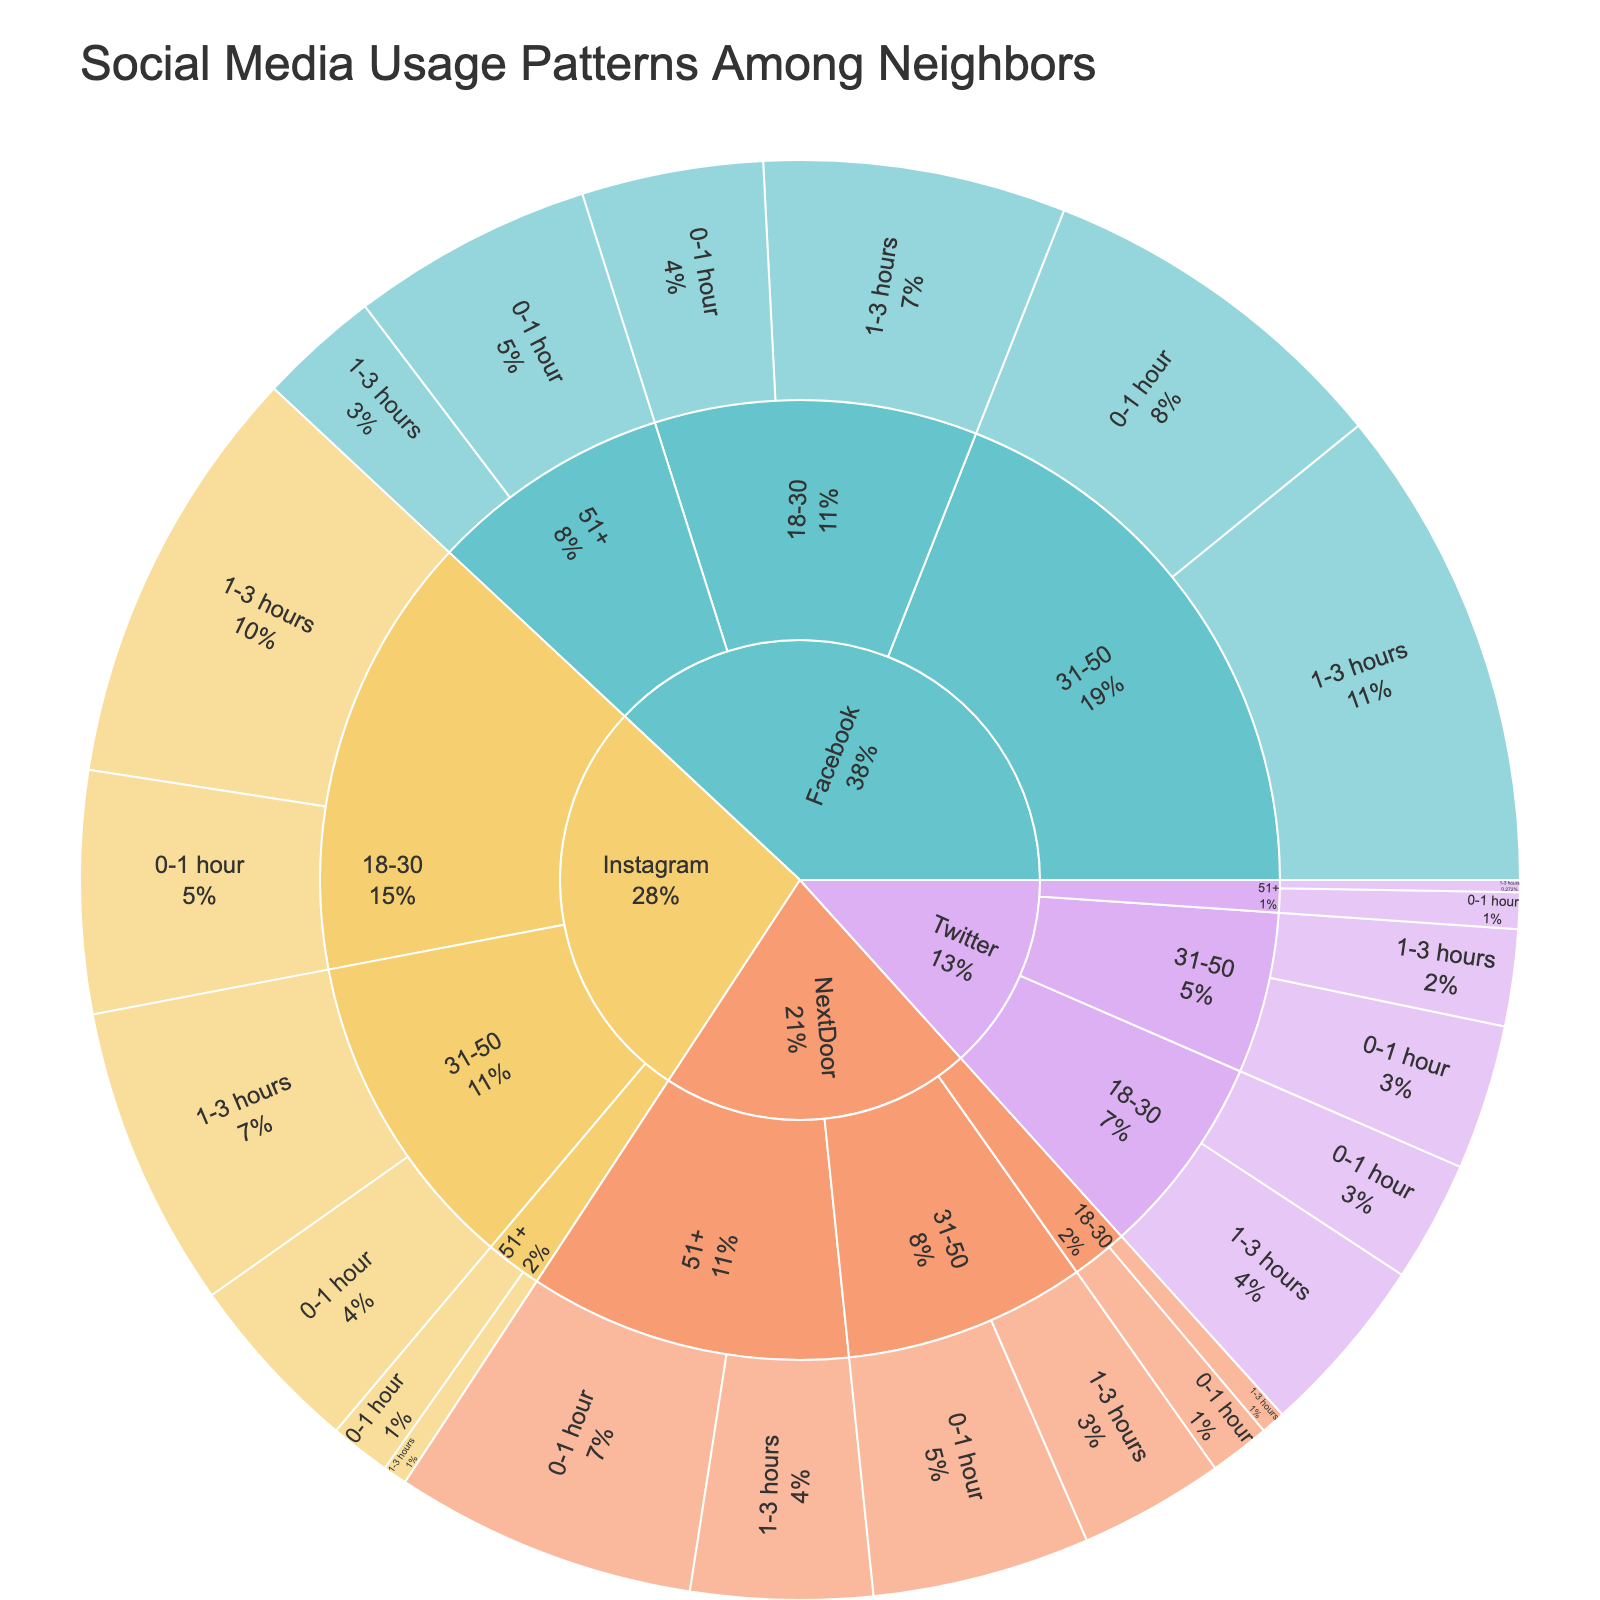What is the overall title of the figure? The overall title can be found at the top of the figure in larger and bold text. It usually provides the main context or subject of the plot. In this case, it is easily observable.
Answer: Social Media Usage Patterns Among Neighbors Which platform has the most users aged 51+ spending 0-1 hour online? To find this, look at the section for each platform (Facebook, Instagram, Twitter, NextDoor) under the '51+' age group and check the '0-1 hour' slice to see the number of users.
Answer: NextDoor How many users aged 18-30 spend 1-3 hours on Instagram? Navigate to the Instagram segment, locate the age group '18-30,' and then check the segment for '1-3 hours' to find the number of users.
Answer: 35 Which age group on Facebook has the highest number of users spending 1-3 hours online? Inspect the Facebook section by age groups (18-30, 31-50, 51+) and compare the corresponding '1-3 hours' segments to see which has the highest user count.
Answer: 31-50 What is the total number of users aged 31-50 on Twitter? Add the number of users in the '31-50' segments for both '0-1 hour' and '1-3 hours' on the Twitter section.
Answer: 20 Which platform has the smallest user base spending 1-3 hours online? Examine the outermost ring sections related to '1-3 hours' for each platform and compare the user counts to find the smallest segment.
Answer: Twitter Compare the number of users aged 51+ spending 1-3 hours on NextDoor and Instagram. Which is larger and by what margin? Locate the '51+' segments for NextDoor and Instagram focusing on '1-3 hours,' then subtract Instagram's count from NextDoor's to determine the difference.
Answer: NextDoor by 13 What percentage of Facebook users aged 18-30 spend 1-3 hours online? Find the total number of users in the '18-30' segment for Facebook, calculate the portion of users spending '1-3 hours,' and then compute the percentage.
Answer: 62.5% Which age group on Instagram has the highest percentage of users spending 0-1 hour online? For each age group on Instagram, compute the percentage of the total users that spend '0-1 hour' online and compare them.
Answer: 31-50 Compare the total number of users spending 0-1 hour to those spending 1-3 hours on all platforms. Which is greater and by how much? Sum the user counts for '0-1 hour' and '1-3 hours' across all platforms, then subtract the smaller total from the larger total to find the difference.
Answer: 188 to 195, by 7 users 